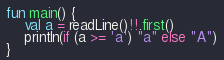Convert code to text. <code><loc_0><loc_0><loc_500><loc_500><_Kotlin_>fun main() {
    val a = readLine()!!.first()
    println(if (a >= 'a') "a" else "A")
}</code> 